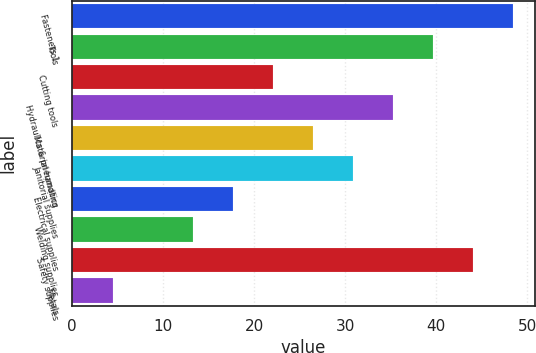Convert chart to OTSL. <chart><loc_0><loc_0><loc_500><loc_500><bar_chart><fcel>Fasteners 1<fcel>Tools<fcel>Cutting tools<fcel>Hydraulics & pneumatics<fcel>Material handling<fcel>Janitorial supplies<fcel>Electrical supplies<fcel>Welding supplies<fcel>Safety supplies<fcel>Metals<nl><fcel>48.39<fcel>39.61<fcel>22.05<fcel>35.22<fcel>26.44<fcel>30.83<fcel>17.66<fcel>13.27<fcel>44<fcel>4.49<nl></chart> 